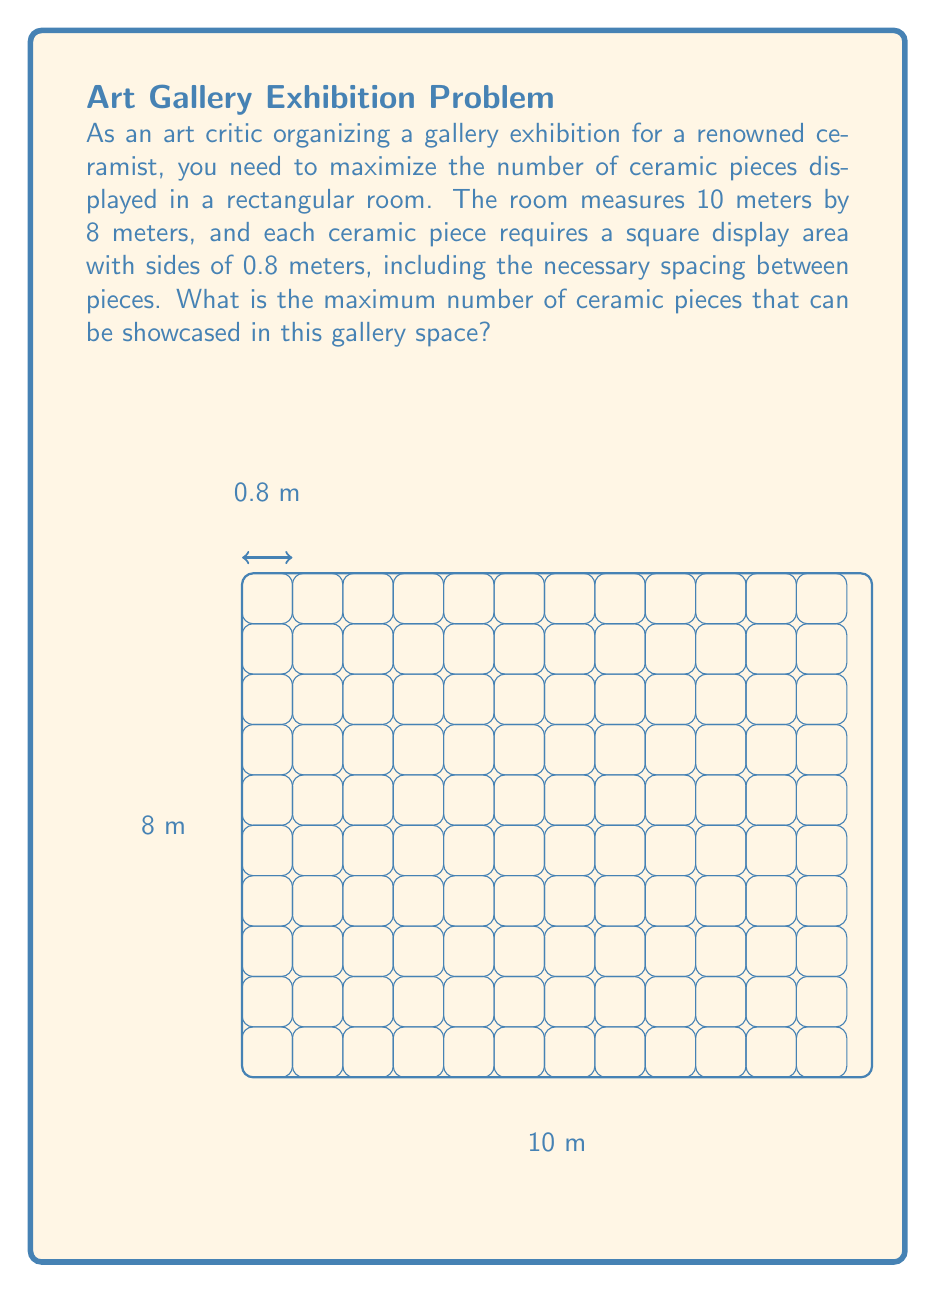Help me with this question. To solve this optimization problem, we'll follow these steps:

1) First, let's calculate how many ceramic pieces can fit along the length and width of the room:

   Length: $\frac{10 \text{ m}}{0.8 \text{ m}} = 12.5$
   Width: $\frac{8 \text{ m}}{0.8 \text{ m}} = 10$

2) Since we can't have fractional pieces, we round down to the nearest whole number:

   Length: 12 pieces
   Width: 10 pieces

3) The total number of pieces that can be displayed is the product of these two numbers:

   $12 \times 10 = 120$ pieces

This arrangement maximizes the use of space while maintaining the required 0.8 m square area for each piece, which includes the necessary spacing between pieces.

It's worth noting that this solution assumes a grid-like arrangement, which is often preferred in gallery settings for its clean and organized appearance. This layout also allows for easy navigation between pieces, enhancing the viewer's experience of the ceramist's innovative work.
Answer: 120 ceramic pieces 